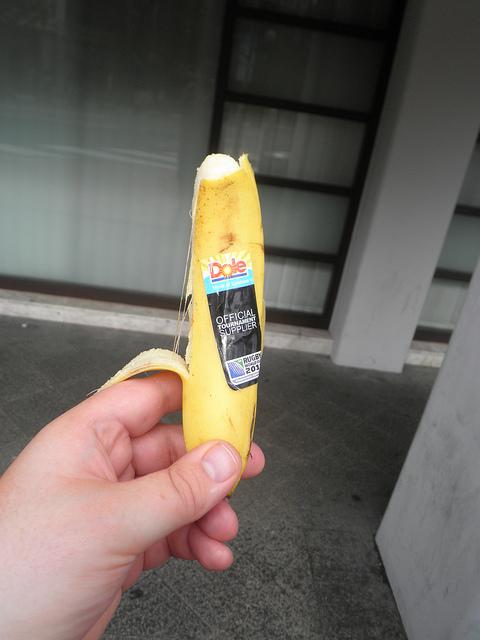What is this person holding?
Give a very brief answer. Banana. What brand is the banana?
Keep it brief. Dole. What traffic tool is shown in the reflection of the window?
Short answer required. Sign. 